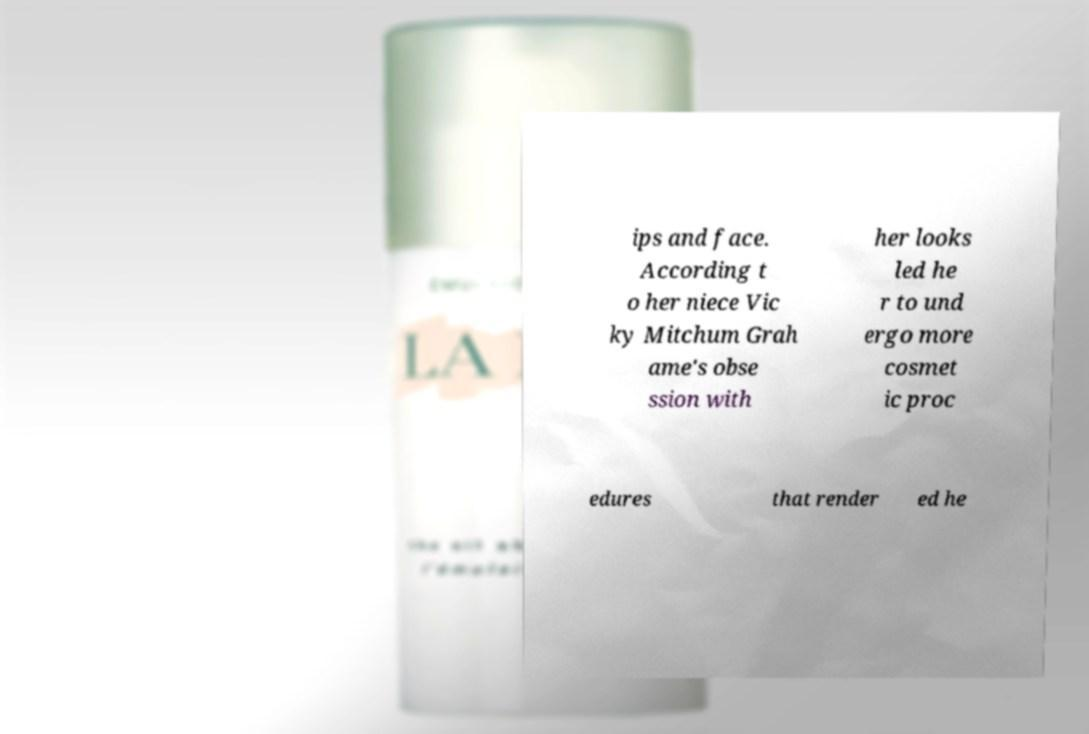I need the written content from this picture converted into text. Can you do that? ips and face. According t o her niece Vic ky Mitchum Grah ame's obse ssion with her looks led he r to und ergo more cosmet ic proc edures that render ed he 